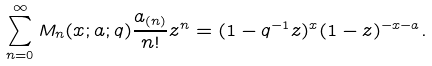<formula> <loc_0><loc_0><loc_500><loc_500>\sum _ { n = 0 } ^ { \infty } M _ { n } ( x ; a ; q ) \frac { a _ { ( n ) } } { n ! } z ^ { n } = ( 1 - q ^ { - 1 } z ) ^ { x } ( 1 - z ) ^ { - x - a } .</formula> 